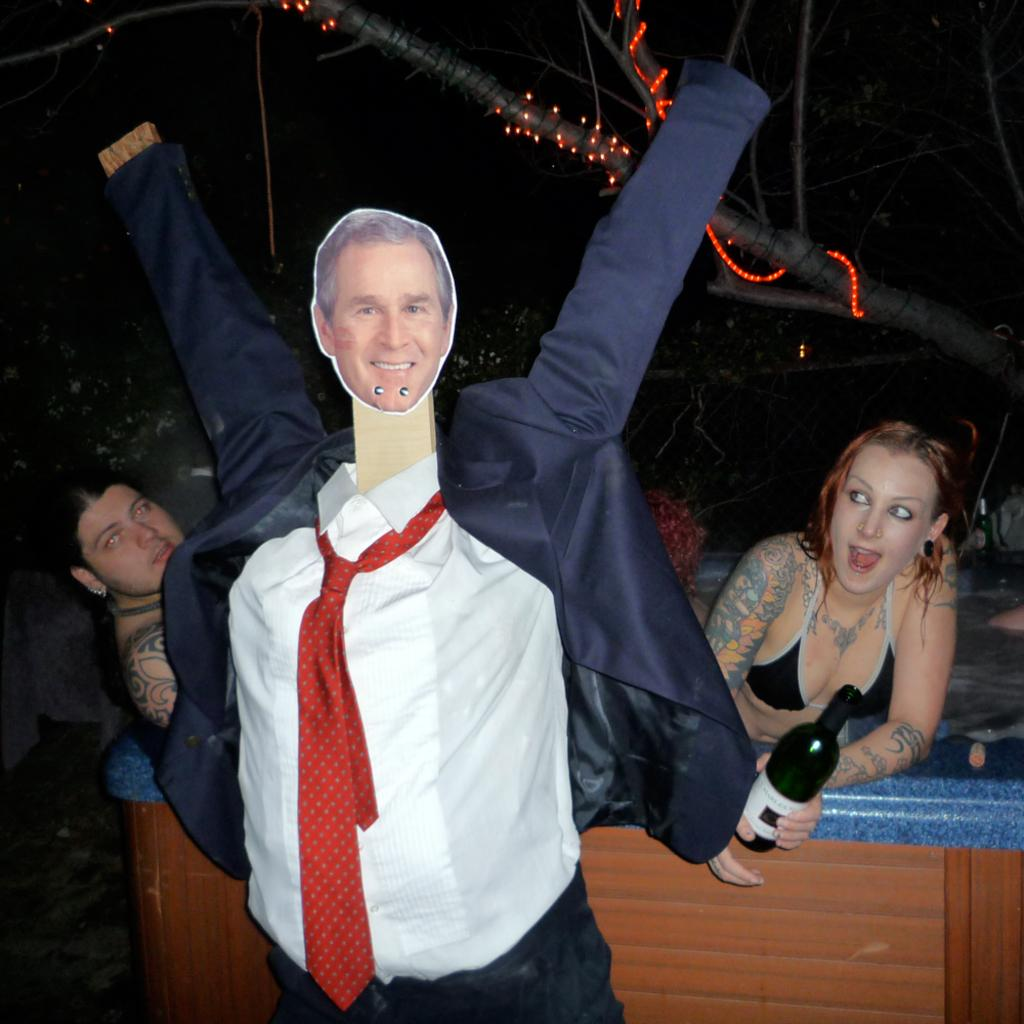How many women are in the image? There are two women in the image. What is one of the women holding in her hand? One of the women is holding a bottle in her hand. What can be seen in the image besides the women? There is a face mask of a man in the image. What is visible in the background of the image? There is a tree visible in the background of the image. How many flies are buzzing around the face mask in the image? There are no flies present in the image; only the face mask of a man is visible. 